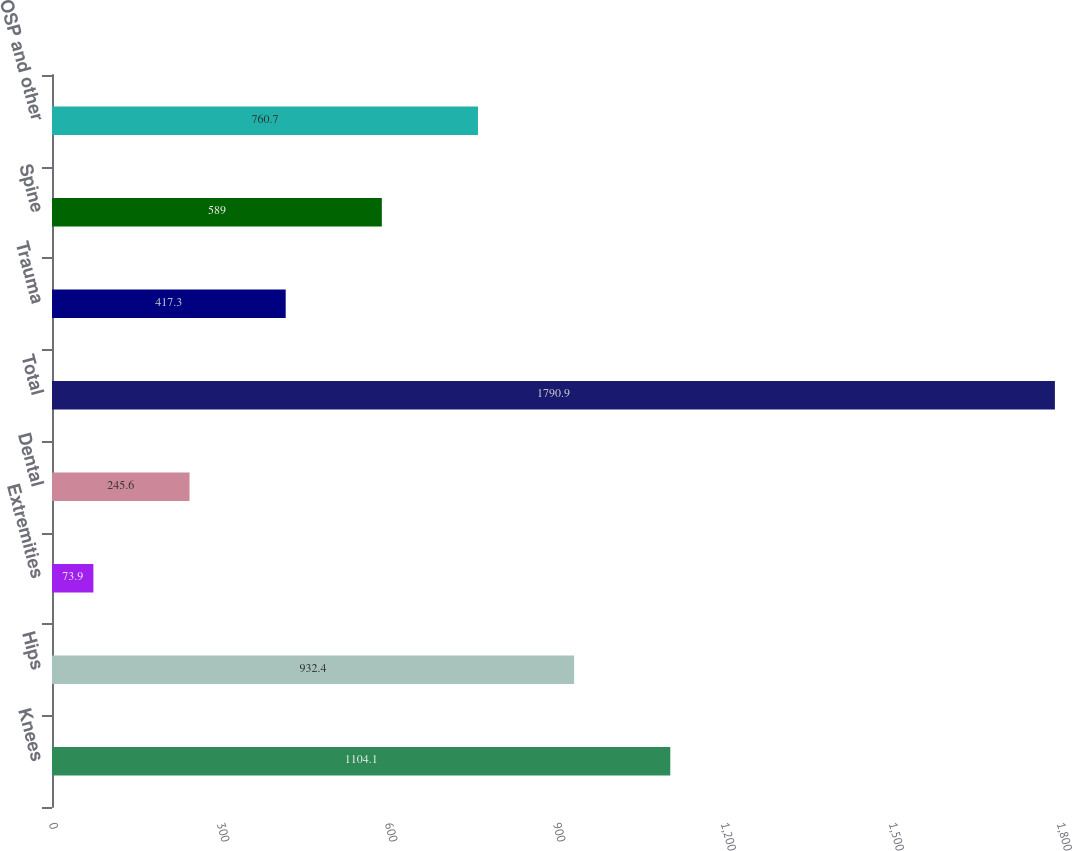Convert chart to OTSL. <chart><loc_0><loc_0><loc_500><loc_500><bar_chart><fcel>Knees<fcel>Hips<fcel>Extremities<fcel>Dental<fcel>Total<fcel>Trauma<fcel>Spine<fcel>OSP and other<nl><fcel>1104.1<fcel>932.4<fcel>73.9<fcel>245.6<fcel>1790.9<fcel>417.3<fcel>589<fcel>760.7<nl></chart> 